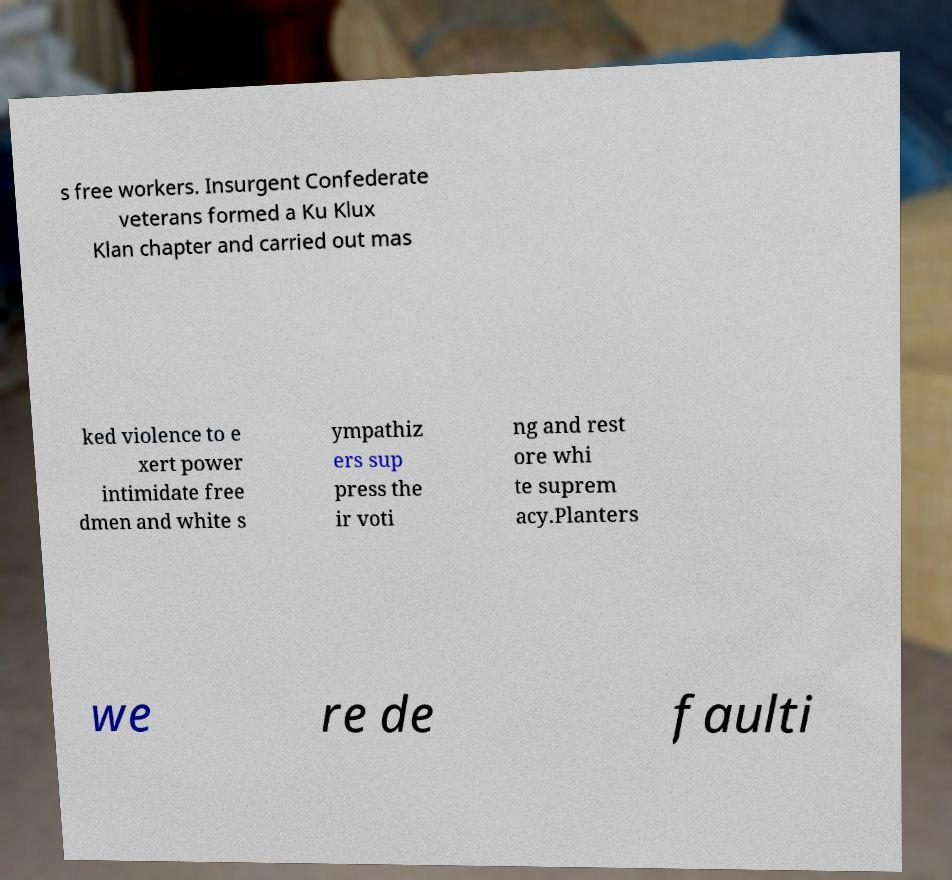Can you accurately transcribe the text from the provided image for me? s free workers. Insurgent Confederate veterans formed a Ku Klux Klan chapter and carried out mas ked violence to e xert power intimidate free dmen and white s ympathiz ers sup press the ir voti ng and rest ore whi te suprem acy.Planters we re de faulti 